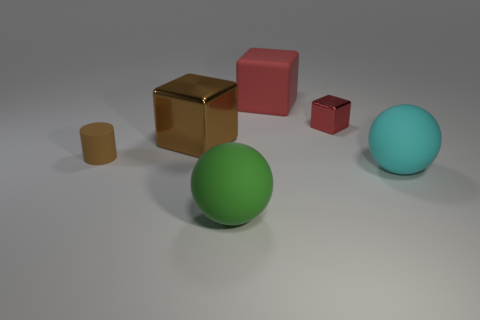Subtract all brown metallic cubes. How many cubes are left? 2 Subtract all gray balls. How many red blocks are left? 2 Add 2 green metallic cylinders. How many objects exist? 8 Subtract all brown cubes. How many cubes are left? 2 Subtract all spheres. How many objects are left? 4 Add 3 cyan balls. How many cyan balls exist? 4 Subtract 0 red cylinders. How many objects are left? 6 Subtract all yellow blocks. Subtract all cyan cylinders. How many blocks are left? 3 Subtract all small gray cylinders. Subtract all large cyan balls. How many objects are left? 5 Add 5 brown cylinders. How many brown cylinders are left? 6 